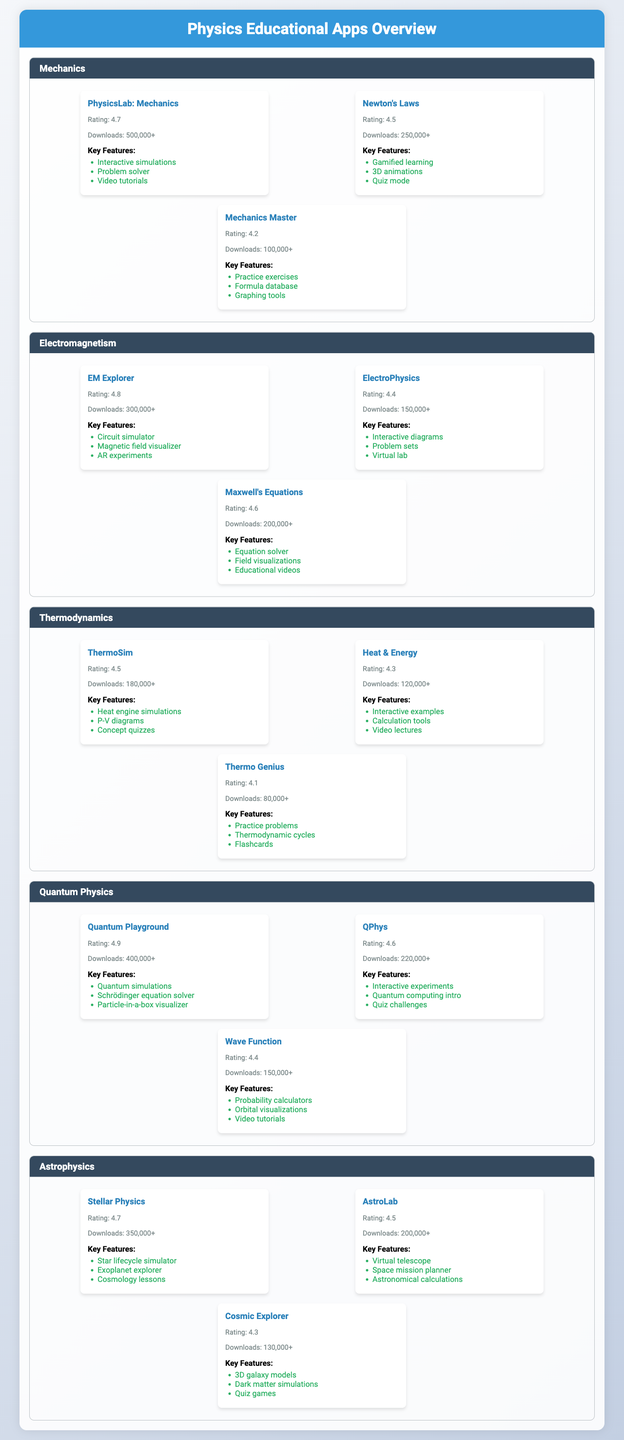What is the user rating of "Quantum Playground"? The user rating for "Quantum Playground" is explicitly listed in the table under the Quantum Physics subject area. It shows a rating of 4.9.
Answer: 4.9 Which subject area has the highest-rated app? To find the subject area with the highest-rated app, we can check each subject’s apps. The highest rating is from "Quantum Playground" (4.9), so the subject area is Quantum Physics.
Answer: Quantum Physics How many downloads does "EM Explorer" have? The table shows that "EM Explorer" has a download count of "300,000+".
Answer: 300,000+ What are the key features of "Mechanics Master"? The table lists the key features of "Mechanics Master" under the Mechanics subject area. They are: "Practice exercises", "Formula database", and "Graphing tools".
Answer: Practice exercises, Formula database, Graphing tools Which app has the lowest user rating in the Thermodynamics category? By evaluating the user ratings of apps under Thermodynamics, we see "Thermo Genius" with a rating of 4.1, which is the lowest in that category.
Answer: Thermo Genius What is the average user rating of apps in the Electromagnetism subject area? The user ratings for Electromagnetism apps are 4.8, 4.4, and 4.6. Calculating the average: (4.8 + 4.4 + 4.6) / 3 = 4.6.
Answer: 4.6 Is "Cosmic Explorer" rated higher than "ThermoSim"? "Cosmic Explorer" has a user rating of 4.3 while "ThermoSim" has a rating of 4.5. Since 4.3 is less than 4.5, the answer is no.
Answer: No How many total downloads do the apps in Astrophysics have combined? The download counts for Astrophysics apps are 350,000+, 200,000+, and 130,000+. Summing them gives us 350,000 + 200,000 + 130,000 = 680,000+.
Answer: 680,000+ Which app, if any, offers "Gamified learning"? Checking the key features for each app, "Newton's Laws" includes "Gamified learning".
Answer: Newton's Laws What is the difference in user ratings between the highest-rated app in Mechanics and the lowest-rated app in Thermodynamics? The highest-rated app in Mechanics is "PhysicsLab: Mechanics" with a rating of 4.7, and the lowest-rated in Thermodynamics is "Thermo Genius" at 4.1. The difference is 4.7 - 4.1 = 0.6.
Answer: 0.6 